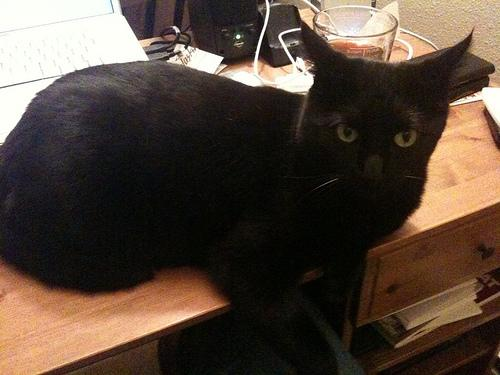What type of woman might this animal be associated with historically? Please explain your reasoning. witch. This animal is a black cat. black cats are not associated with medical professionals. 